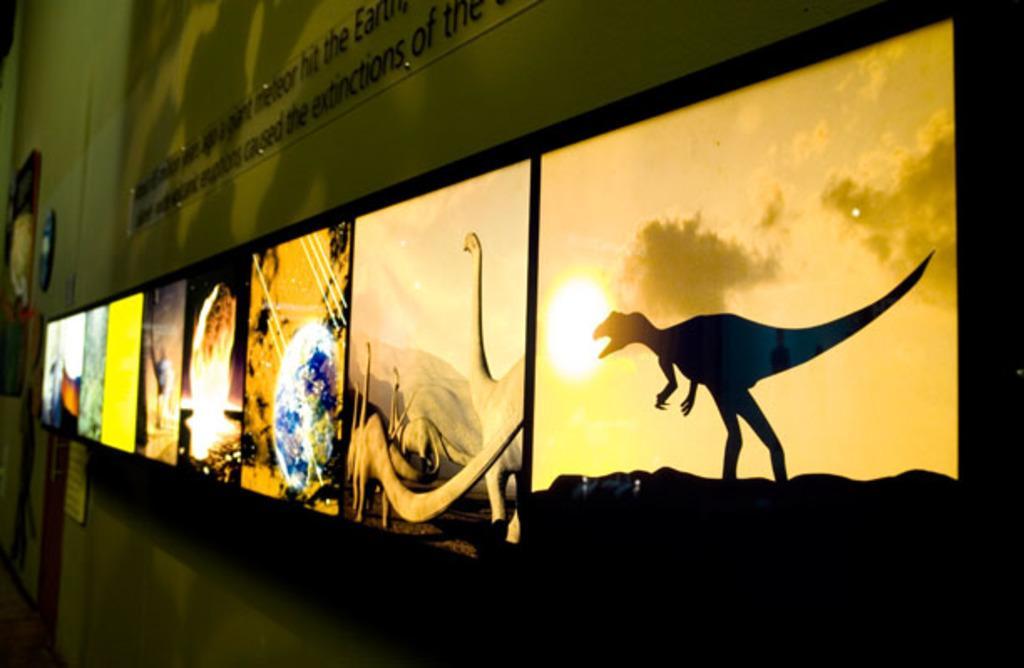Please provide a concise description of this image. In this picture I can see frames and a glass board attached to the wall. 